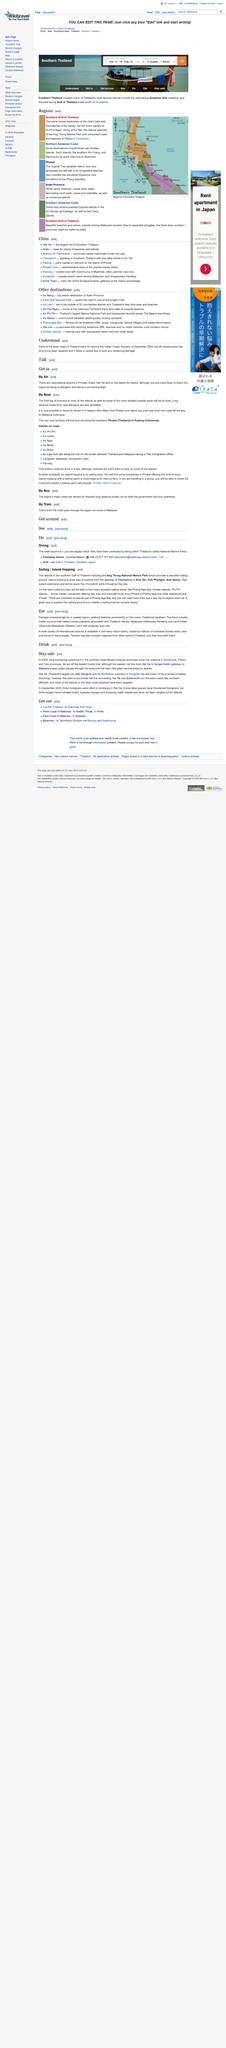Identify some key points in this picture. The colors on the land section of the map designate the regions of Southern Thailand. Ko Lipe is a hub located at the border between Thailand and Malaysia, which is known for its unique geographical location between the two countries. The West Coast is home to a variety of stunning sailing areas, including Phang Nga Bay, the Similan Islands, and the Phi Phi Islands. These areas offer breathtaking scenery and exceptional sailing conditions, making them popular destinations for sailors and boaters alike. Ranong is a destination that is renowned for its popular visa-runs to Myanmar. The full moon parties are held on the island of Ko Pha Ngan. 